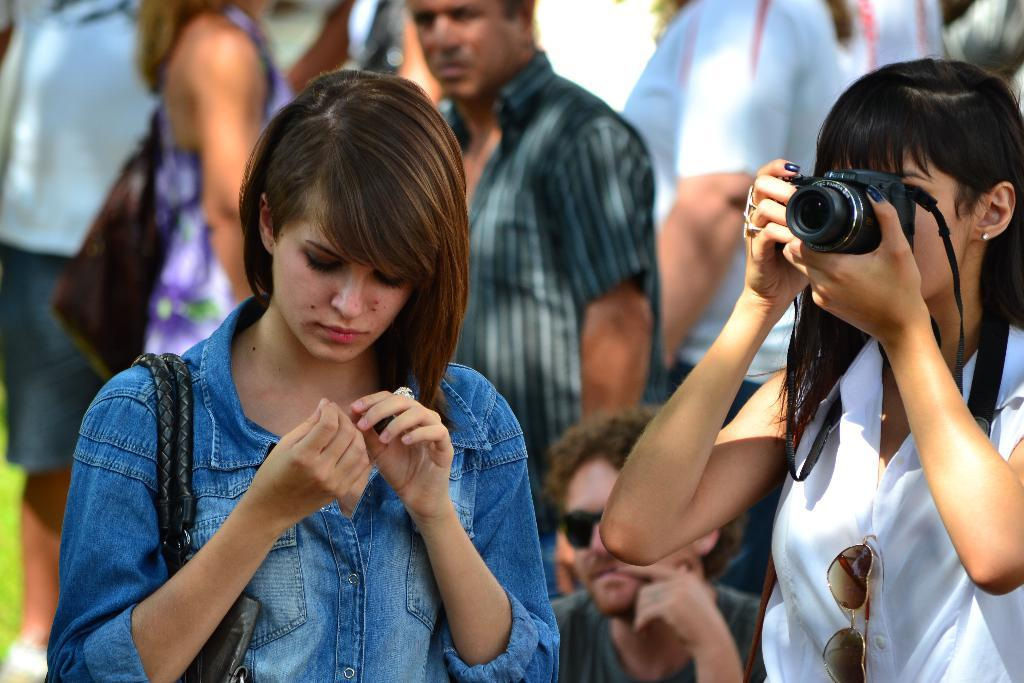What is happening in the image? There are people standing in the image. Can you describe one of the individuals in the image? There is a woman in the image. What is the woman holding in her hand? The woman is holding a camera in her hand. Can you see any robins perched on the camera in the image? There are no robins present in the image. 